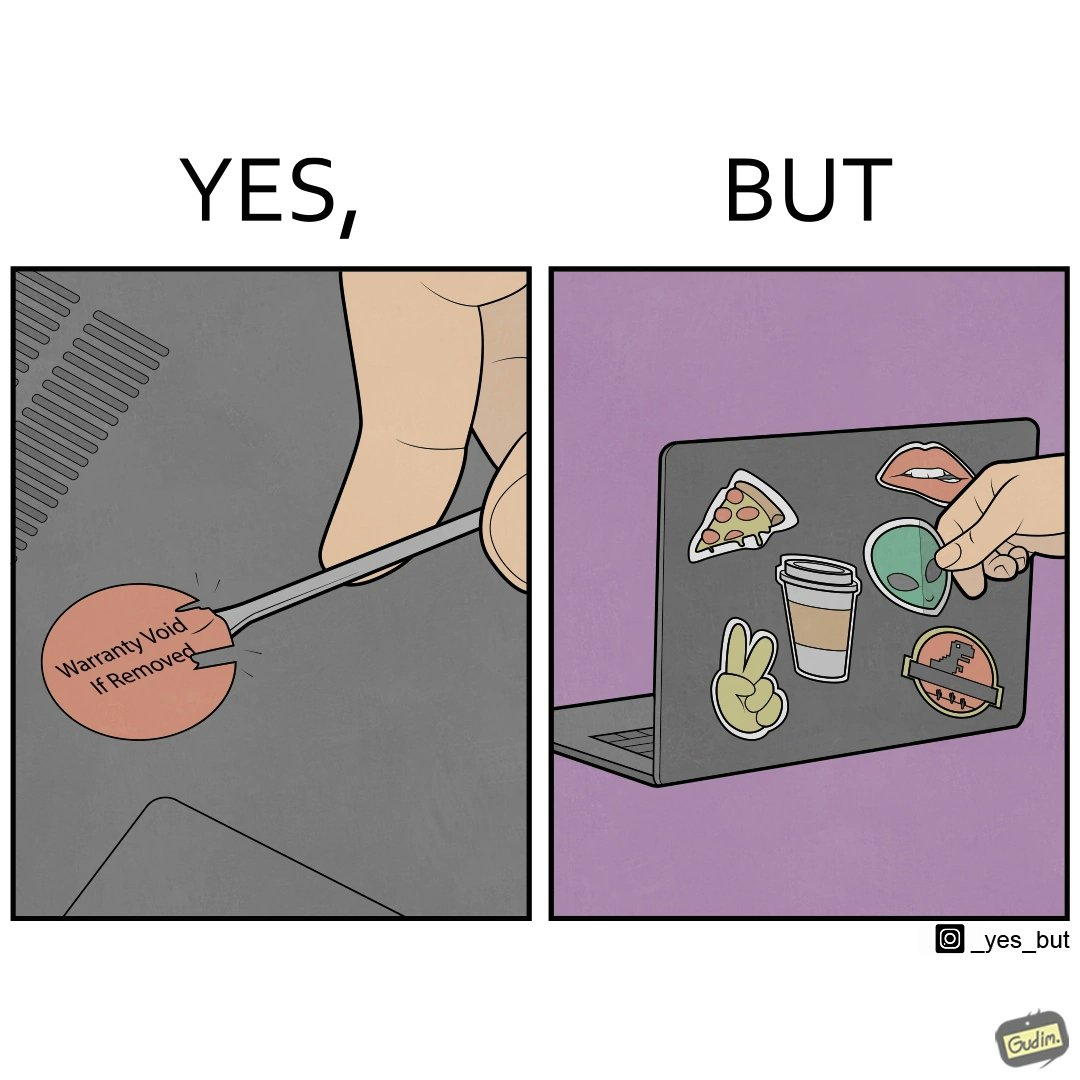Describe what you see in this image. The images are funny since it shows how an user chooses to remove a rather important warranty sticker because it does not look good, but chooses to fill his laptop with useless stickers just to decorate the laptop 